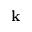Convert formula to latex. <formula><loc_0><loc_0><loc_500><loc_500>k</formula> 